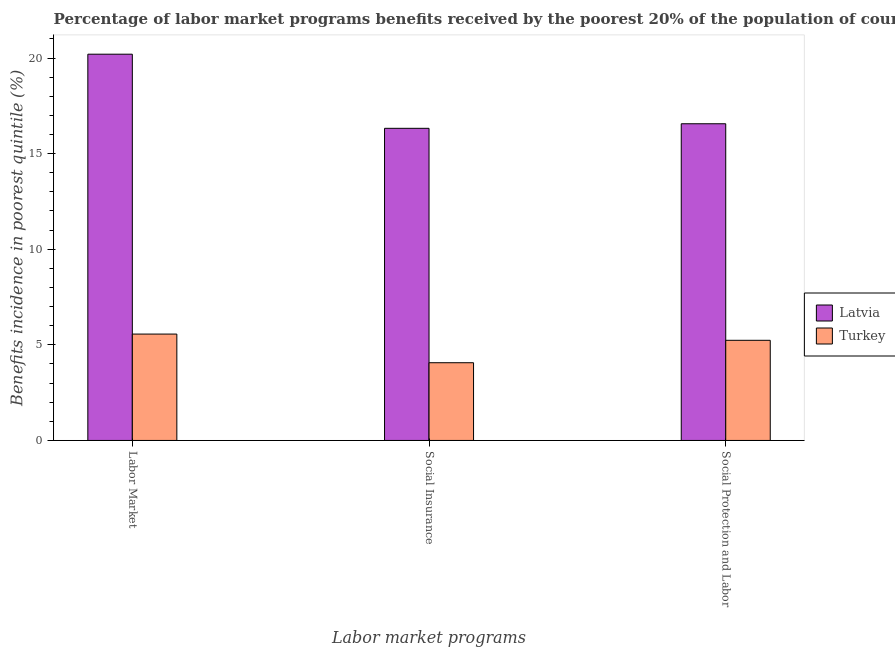How many different coloured bars are there?
Make the answer very short. 2. Are the number of bars per tick equal to the number of legend labels?
Your response must be concise. Yes. How many bars are there on the 1st tick from the left?
Your answer should be very brief. 2. What is the label of the 1st group of bars from the left?
Provide a short and direct response. Labor Market. What is the percentage of benefits received due to social protection programs in Turkey?
Keep it short and to the point. 5.24. Across all countries, what is the maximum percentage of benefits received due to labor market programs?
Ensure brevity in your answer.  20.2. Across all countries, what is the minimum percentage of benefits received due to social insurance programs?
Your answer should be very brief. 4.06. In which country was the percentage of benefits received due to labor market programs maximum?
Make the answer very short. Latvia. What is the total percentage of benefits received due to social protection programs in the graph?
Your response must be concise. 21.8. What is the difference between the percentage of benefits received due to social protection programs in Latvia and that in Turkey?
Provide a succinct answer. 11.33. What is the difference between the percentage of benefits received due to labor market programs in Latvia and the percentage of benefits received due to social protection programs in Turkey?
Your answer should be very brief. 14.96. What is the average percentage of benefits received due to labor market programs per country?
Make the answer very short. 12.88. What is the difference between the percentage of benefits received due to social insurance programs and percentage of benefits received due to labor market programs in Latvia?
Your answer should be compact. -3.88. In how many countries, is the percentage of benefits received due to social insurance programs greater than 16 %?
Provide a short and direct response. 1. What is the ratio of the percentage of benefits received due to social protection programs in Latvia to that in Turkey?
Keep it short and to the point. 3.16. Is the percentage of benefits received due to social insurance programs in Latvia less than that in Turkey?
Provide a succinct answer. No. Is the difference between the percentage of benefits received due to social protection programs in Latvia and Turkey greater than the difference between the percentage of benefits received due to labor market programs in Latvia and Turkey?
Give a very brief answer. No. What is the difference between the highest and the second highest percentage of benefits received due to labor market programs?
Your response must be concise. 14.64. What is the difference between the highest and the lowest percentage of benefits received due to social protection programs?
Provide a short and direct response. 11.33. In how many countries, is the percentage of benefits received due to social insurance programs greater than the average percentage of benefits received due to social insurance programs taken over all countries?
Your answer should be compact. 1. Is the sum of the percentage of benefits received due to labor market programs in Latvia and Turkey greater than the maximum percentage of benefits received due to social insurance programs across all countries?
Offer a very short reply. Yes. What does the 1st bar from the left in Social Insurance represents?
Offer a very short reply. Latvia. What does the 2nd bar from the right in Social Insurance represents?
Your response must be concise. Latvia. How many bars are there?
Offer a very short reply. 6. Are all the bars in the graph horizontal?
Your response must be concise. No. How many countries are there in the graph?
Your answer should be very brief. 2. What is the difference between two consecutive major ticks on the Y-axis?
Provide a short and direct response. 5. What is the title of the graph?
Offer a terse response. Percentage of labor market programs benefits received by the poorest 20% of the population of countries. Does "Colombia" appear as one of the legend labels in the graph?
Provide a short and direct response. No. What is the label or title of the X-axis?
Offer a very short reply. Labor market programs. What is the label or title of the Y-axis?
Your answer should be compact. Benefits incidence in poorest quintile (%). What is the Benefits incidence in poorest quintile (%) of Latvia in Labor Market?
Keep it short and to the point. 20.2. What is the Benefits incidence in poorest quintile (%) in Turkey in Labor Market?
Your response must be concise. 5.56. What is the Benefits incidence in poorest quintile (%) of Latvia in Social Insurance?
Your answer should be compact. 16.32. What is the Benefits incidence in poorest quintile (%) in Turkey in Social Insurance?
Offer a terse response. 4.06. What is the Benefits incidence in poorest quintile (%) in Latvia in Social Protection and Labor?
Give a very brief answer. 16.56. What is the Benefits incidence in poorest quintile (%) in Turkey in Social Protection and Labor?
Your response must be concise. 5.24. Across all Labor market programs, what is the maximum Benefits incidence in poorest quintile (%) in Latvia?
Provide a short and direct response. 20.2. Across all Labor market programs, what is the maximum Benefits incidence in poorest quintile (%) in Turkey?
Your answer should be compact. 5.56. Across all Labor market programs, what is the minimum Benefits incidence in poorest quintile (%) in Latvia?
Keep it short and to the point. 16.32. Across all Labor market programs, what is the minimum Benefits incidence in poorest quintile (%) in Turkey?
Offer a very short reply. 4.06. What is the total Benefits incidence in poorest quintile (%) in Latvia in the graph?
Provide a short and direct response. 53.09. What is the total Benefits incidence in poorest quintile (%) of Turkey in the graph?
Keep it short and to the point. 14.87. What is the difference between the Benefits incidence in poorest quintile (%) of Latvia in Labor Market and that in Social Insurance?
Your response must be concise. 3.88. What is the difference between the Benefits incidence in poorest quintile (%) in Turkey in Labor Market and that in Social Insurance?
Keep it short and to the point. 1.5. What is the difference between the Benefits incidence in poorest quintile (%) in Latvia in Labor Market and that in Social Protection and Labor?
Provide a succinct answer. 3.64. What is the difference between the Benefits incidence in poorest quintile (%) in Turkey in Labor Market and that in Social Protection and Labor?
Keep it short and to the point. 0.33. What is the difference between the Benefits incidence in poorest quintile (%) of Latvia in Social Insurance and that in Social Protection and Labor?
Give a very brief answer. -0.24. What is the difference between the Benefits incidence in poorest quintile (%) in Turkey in Social Insurance and that in Social Protection and Labor?
Offer a very short reply. -1.17. What is the difference between the Benefits incidence in poorest quintile (%) in Latvia in Labor Market and the Benefits incidence in poorest quintile (%) in Turkey in Social Insurance?
Give a very brief answer. 16.14. What is the difference between the Benefits incidence in poorest quintile (%) of Latvia in Labor Market and the Benefits incidence in poorest quintile (%) of Turkey in Social Protection and Labor?
Ensure brevity in your answer.  14.96. What is the difference between the Benefits incidence in poorest quintile (%) in Latvia in Social Insurance and the Benefits incidence in poorest quintile (%) in Turkey in Social Protection and Labor?
Keep it short and to the point. 11.09. What is the average Benefits incidence in poorest quintile (%) in Latvia per Labor market programs?
Keep it short and to the point. 17.7. What is the average Benefits incidence in poorest quintile (%) of Turkey per Labor market programs?
Make the answer very short. 4.96. What is the difference between the Benefits incidence in poorest quintile (%) in Latvia and Benefits incidence in poorest quintile (%) in Turkey in Labor Market?
Offer a very short reply. 14.64. What is the difference between the Benefits incidence in poorest quintile (%) of Latvia and Benefits incidence in poorest quintile (%) of Turkey in Social Insurance?
Offer a very short reply. 12.26. What is the difference between the Benefits incidence in poorest quintile (%) of Latvia and Benefits incidence in poorest quintile (%) of Turkey in Social Protection and Labor?
Ensure brevity in your answer.  11.33. What is the ratio of the Benefits incidence in poorest quintile (%) in Latvia in Labor Market to that in Social Insurance?
Ensure brevity in your answer.  1.24. What is the ratio of the Benefits incidence in poorest quintile (%) of Turkey in Labor Market to that in Social Insurance?
Your answer should be very brief. 1.37. What is the ratio of the Benefits incidence in poorest quintile (%) in Latvia in Labor Market to that in Social Protection and Labor?
Your response must be concise. 1.22. What is the ratio of the Benefits incidence in poorest quintile (%) in Turkey in Labor Market to that in Social Protection and Labor?
Keep it short and to the point. 1.06. What is the ratio of the Benefits incidence in poorest quintile (%) of Latvia in Social Insurance to that in Social Protection and Labor?
Give a very brief answer. 0.99. What is the ratio of the Benefits incidence in poorest quintile (%) in Turkey in Social Insurance to that in Social Protection and Labor?
Keep it short and to the point. 0.78. What is the difference between the highest and the second highest Benefits incidence in poorest quintile (%) in Latvia?
Make the answer very short. 3.64. What is the difference between the highest and the second highest Benefits incidence in poorest quintile (%) of Turkey?
Your answer should be very brief. 0.33. What is the difference between the highest and the lowest Benefits incidence in poorest quintile (%) in Latvia?
Offer a terse response. 3.88. What is the difference between the highest and the lowest Benefits incidence in poorest quintile (%) in Turkey?
Provide a succinct answer. 1.5. 